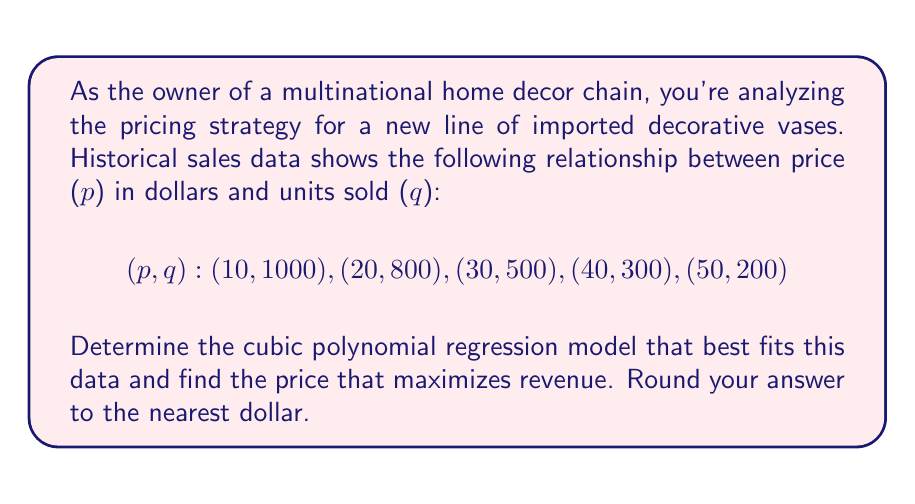Show me your answer to this math problem. 1) We'll use a cubic polynomial model: $q = ap^3 + bp^2 + cp + d$

2) To find the coefficients, we'll use a system of equations:
   $$1000 = 10^3a + 10^2b + 10c + d$$
   $$800 = 20^3a + 20^2b + 20c + d$$
   $$500 = 30^3a + 30^2b + 30c + d$$
   $$300 = 40^3a + 40^2b + 40c + d$$
   $$200 = 50^3a + 50^2b + 50c + d$$

3) Solving this system (using a computer algebra system) gives:
   $$a \approx 0.0004, b \approx -0.0536, c \approx 1.8, d \approx 1020$$

4) Our model is: $q = 0.0004p^3 - 0.0536p^2 + 1.8p + 1020$

5) Revenue R is price times quantity: $R = pq$
   $$R = p(0.0004p^3 - 0.0536p^2 + 1.8p + 1020)$$
   $$R = 0.0004p^4 - 0.0536p^3 + 1.8p^2 + 1020p$$

6) To maximize revenue, we find where $\frac{dR}{dp} = 0$:
   $$\frac{dR}{dp} = 0.0016p^3 - 0.1608p^2 + 3.6p + 1020 = 0$$

7) Solving this equation (again, using a computer algebra system) gives p ≈ 28.13

8) Rounding to the nearest dollar gives us $28.
Answer: $28 